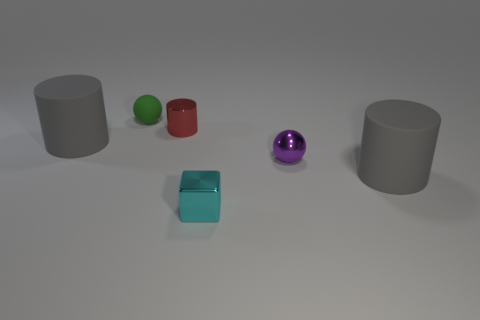Subtract all gray cylinders. How many cylinders are left? 1 Subtract all green balls. How many gray cylinders are left? 2 Subtract 1 cylinders. How many cylinders are left? 2 Add 4 small cyan things. How many objects exist? 10 Subtract all blocks. How many objects are left? 5 Subtract all matte cylinders. Subtract all cylinders. How many objects are left? 1 Add 5 tiny green rubber balls. How many tiny green rubber balls are left? 6 Add 3 gray rubber things. How many gray rubber things exist? 5 Subtract 0 purple blocks. How many objects are left? 6 